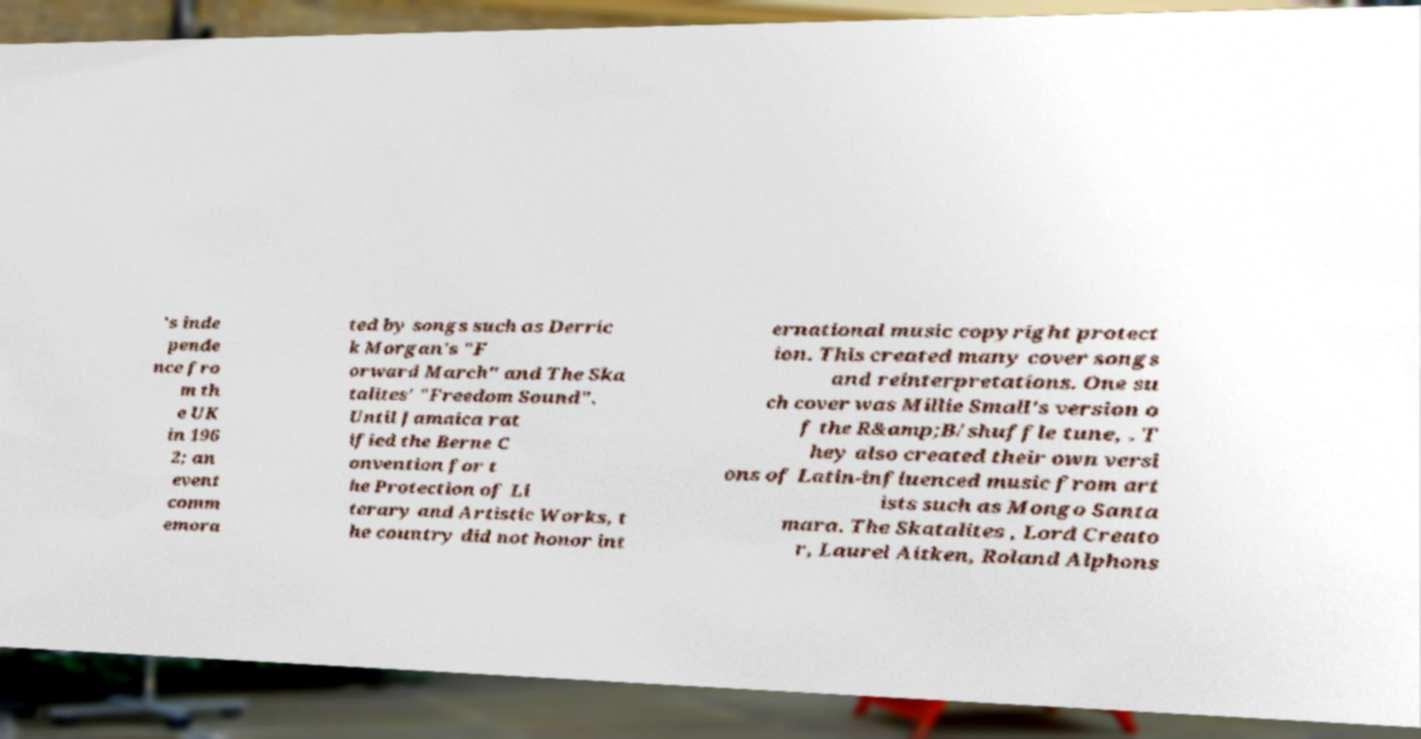I need the written content from this picture converted into text. Can you do that? 's inde pende nce fro m th e UK in 196 2; an event comm emora ted by songs such as Derric k Morgan's "F orward March" and The Ska talites' "Freedom Sound". Until Jamaica rat ified the Berne C onvention for t he Protection of Li terary and Artistic Works, t he country did not honor int ernational music copyright protect ion. This created many cover songs and reinterpretations. One su ch cover was Millie Small's version o f the R&amp;B/shuffle tune, . T hey also created their own versi ons of Latin-influenced music from art ists such as Mongo Santa mara. The Skatalites , Lord Creato r, Laurel Aitken, Roland Alphons 